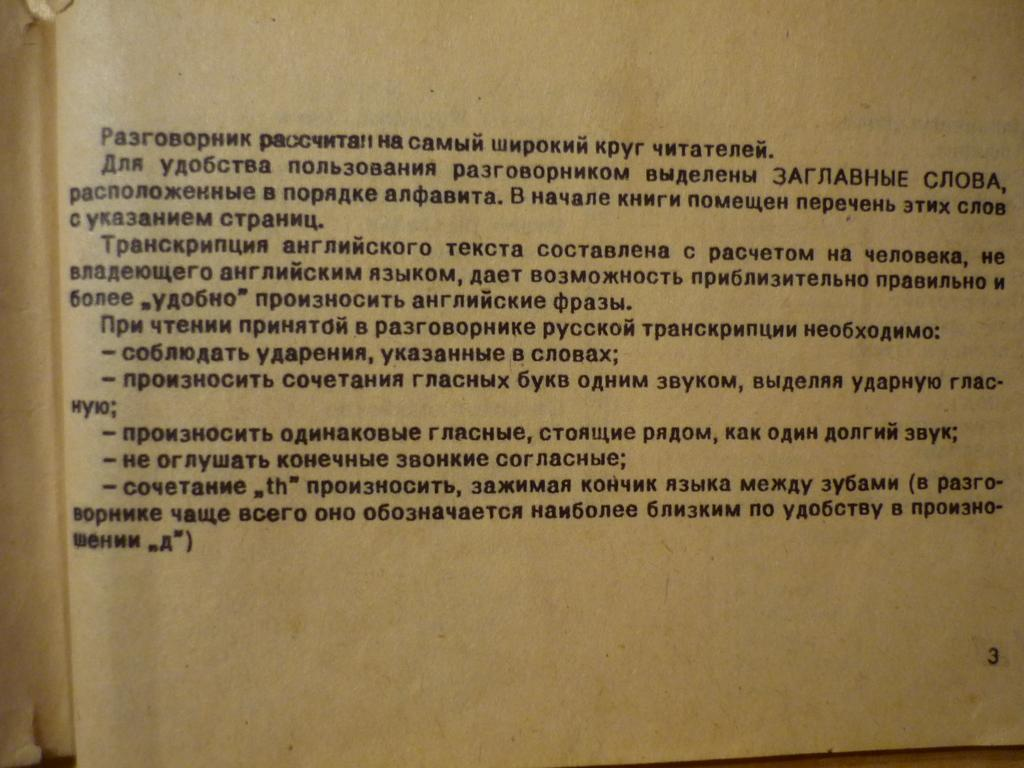<image>
Share a concise interpretation of the image provided. Page 3 of an open book ends with a statement in parentheses. 